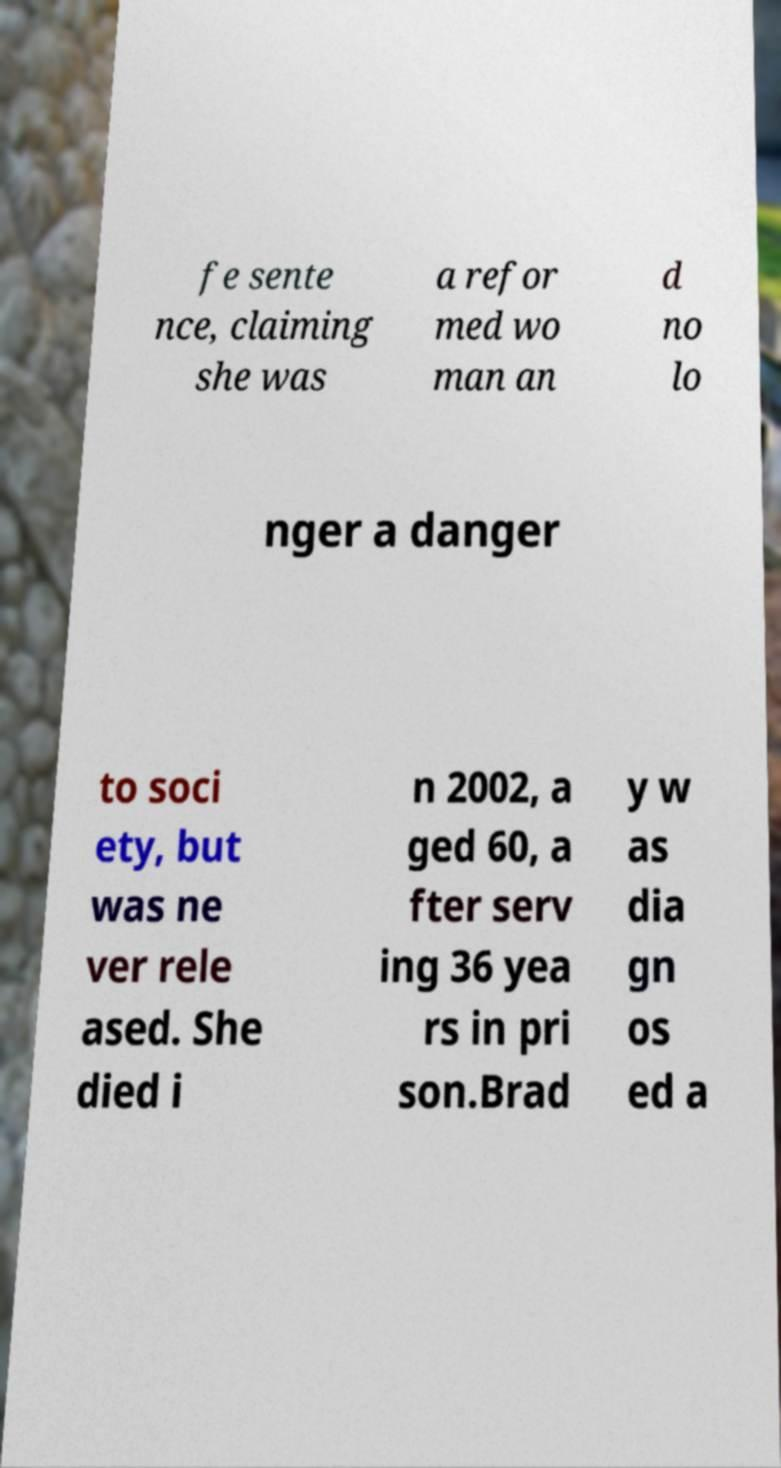Could you extract and type out the text from this image? fe sente nce, claiming she was a refor med wo man an d no lo nger a danger to soci ety, but was ne ver rele ased. She died i n 2002, a ged 60, a fter serv ing 36 yea rs in pri son.Brad y w as dia gn os ed a 